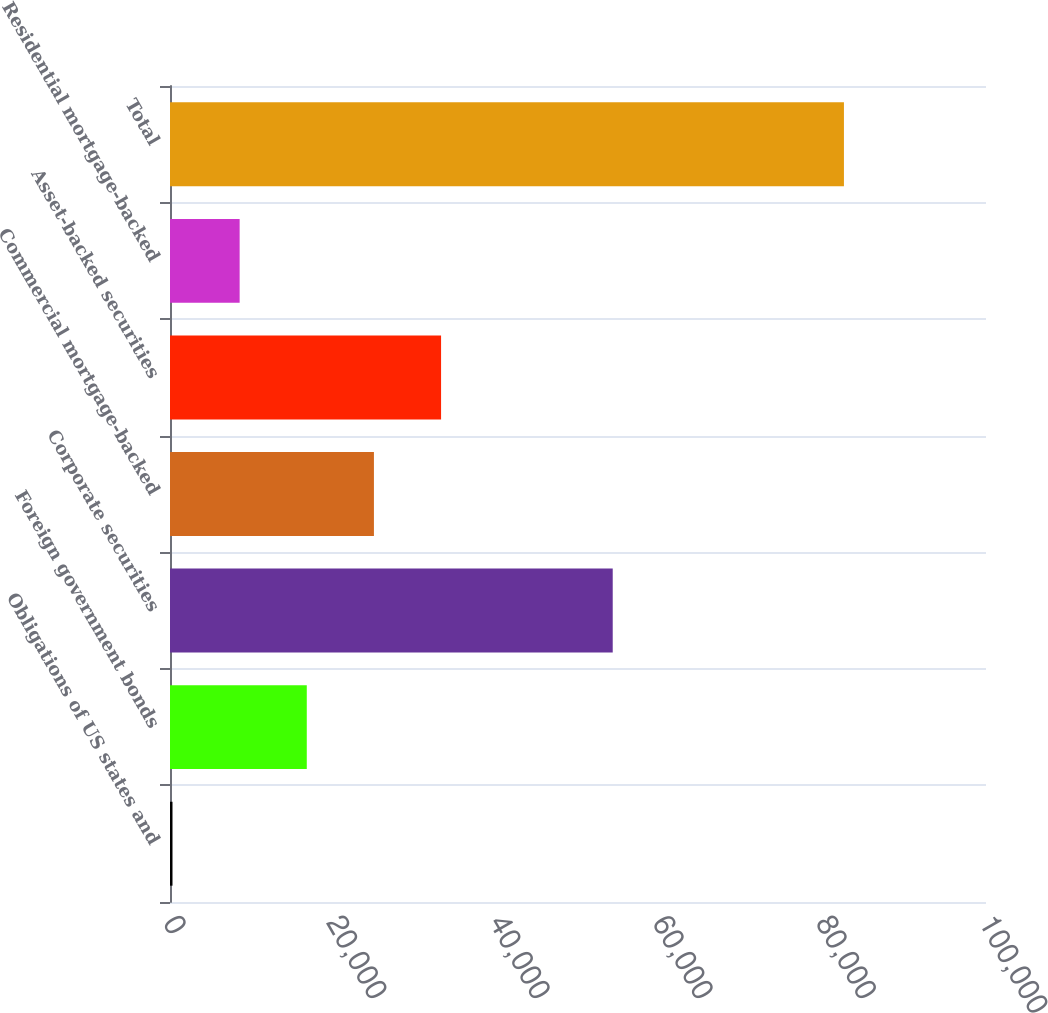Convert chart to OTSL. <chart><loc_0><loc_0><loc_500><loc_500><bar_chart><fcel>Obligations of US states and<fcel>Foreign government bonds<fcel>Corporate securities<fcel>Commercial mortgage-backed<fcel>Asset-backed securities<fcel>Residential mortgage-backed<fcel>Total<nl><fcel>306<fcel>16762.8<fcel>54256<fcel>24991.2<fcel>33219.6<fcel>8534.4<fcel>82590<nl></chart> 